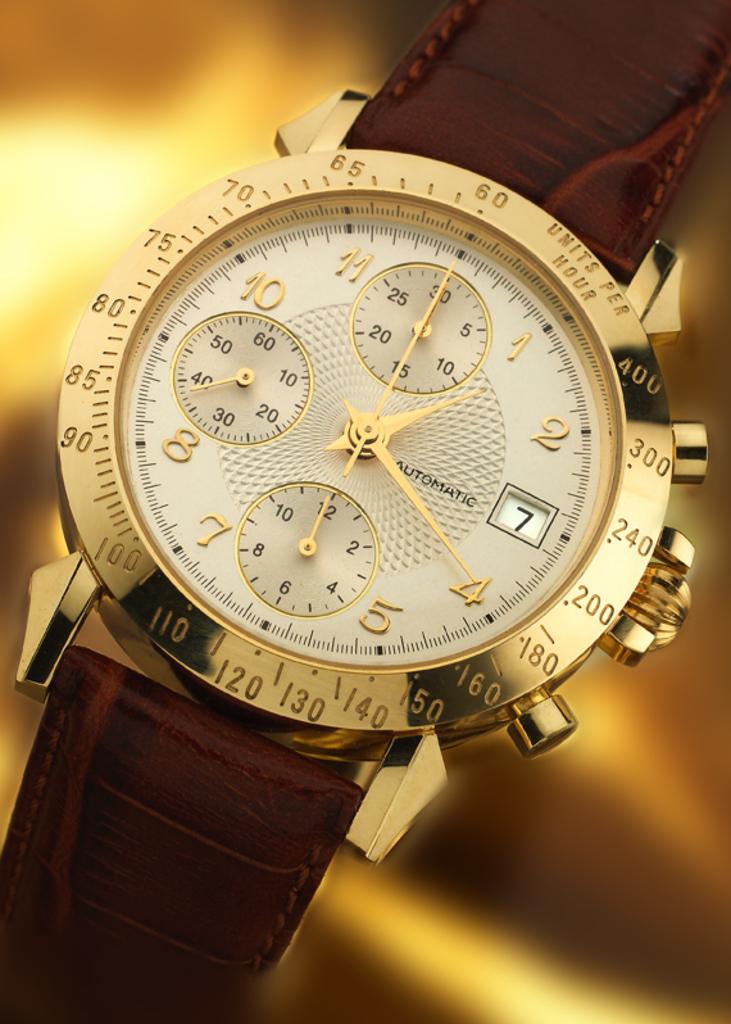What time is it?
Ensure brevity in your answer.  1:20. 